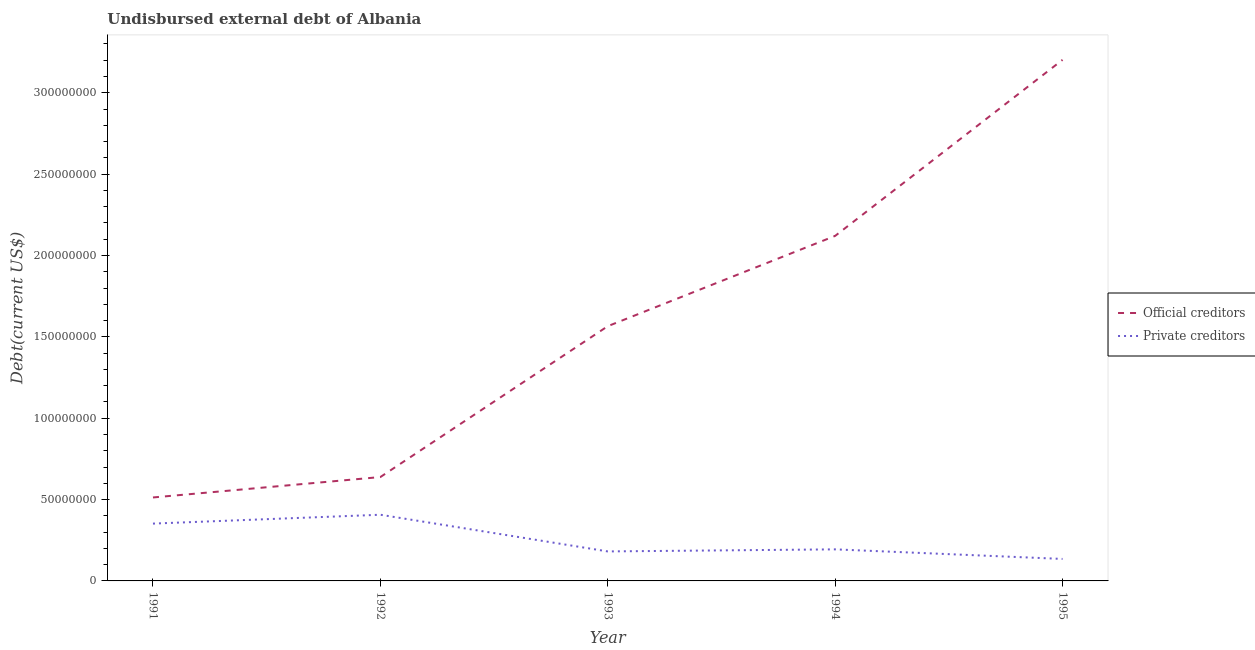Is the number of lines equal to the number of legend labels?
Ensure brevity in your answer.  Yes. What is the undisbursed external debt of private creditors in 1993?
Your answer should be very brief. 1.81e+07. Across all years, what is the maximum undisbursed external debt of official creditors?
Your answer should be very brief. 3.20e+08. Across all years, what is the minimum undisbursed external debt of private creditors?
Make the answer very short. 1.35e+07. In which year was the undisbursed external debt of official creditors minimum?
Keep it short and to the point. 1991. What is the total undisbursed external debt of private creditors in the graph?
Offer a very short reply. 1.27e+08. What is the difference between the undisbursed external debt of private creditors in 1993 and that in 1994?
Ensure brevity in your answer.  -1.27e+06. What is the difference between the undisbursed external debt of official creditors in 1991 and the undisbursed external debt of private creditors in 1994?
Your answer should be very brief. 3.19e+07. What is the average undisbursed external debt of private creditors per year?
Make the answer very short. 2.54e+07. In the year 1994, what is the difference between the undisbursed external debt of official creditors and undisbursed external debt of private creditors?
Your response must be concise. 1.93e+08. In how many years, is the undisbursed external debt of official creditors greater than 80000000 US$?
Provide a succinct answer. 3. What is the ratio of the undisbursed external debt of official creditors in 1992 to that in 1994?
Give a very brief answer. 0.3. Is the difference between the undisbursed external debt of official creditors in 1994 and 1995 greater than the difference between the undisbursed external debt of private creditors in 1994 and 1995?
Your response must be concise. No. What is the difference between the highest and the second highest undisbursed external debt of private creditors?
Make the answer very short. 5.44e+06. What is the difference between the highest and the lowest undisbursed external debt of private creditors?
Offer a very short reply. 2.72e+07. In how many years, is the undisbursed external debt of private creditors greater than the average undisbursed external debt of private creditors taken over all years?
Provide a succinct answer. 2. Does the undisbursed external debt of private creditors monotonically increase over the years?
Give a very brief answer. No. Is the undisbursed external debt of official creditors strictly greater than the undisbursed external debt of private creditors over the years?
Provide a short and direct response. Yes. Is the undisbursed external debt of private creditors strictly less than the undisbursed external debt of official creditors over the years?
Your response must be concise. Yes. How many years are there in the graph?
Your response must be concise. 5. Are the values on the major ticks of Y-axis written in scientific E-notation?
Your answer should be very brief. No. Does the graph contain any zero values?
Your answer should be compact. No. How many legend labels are there?
Make the answer very short. 2. How are the legend labels stacked?
Give a very brief answer. Vertical. What is the title of the graph?
Provide a succinct answer. Undisbursed external debt of Albania. Does "Electricity and heat production" appear as one of the legend labels in the graph?
Offer a terse response. No. What is the label or title of the Y-axis?
Make the answer very short. Debt(current US$). What is the Debt(current US$) of Official creditors in 1991?
Your answer should be very brief. 5.13e+07. What is the Debt(current US$) of Private creditors in 1991?
Make the answer very short. 3.52e+07. What is the Debt(current US$) of Official creditors in 1992?
Keep it short and to the point. 6.38e+07. What is the Debt(current US$) in Private creditors in 1992?
Give a very brief answer. 4.07e+07. What is the Debt(current US$) in Official creditors in 1993?
Offer a very short reply. 1.57e+08. What is the Debt(current US$) of Private creditors in 1993?
Keep it short and to the point. 1.81e+07. What is the Debt(current US$) in Official creditors in 1994?
Your response must be concise. 2.12e+08. What is the Debt(current US$) of Private creditors in 1994?
Offer a terse response. 1.94e+07. What is the Debt(current US$) in Official creditors in 1995?
Offer a very short reply. 3.20e+08. What is the Debt(current US$) of Private creditors in 1995?
Your response must be concise. 1.35e+07. Across all years, what is the maximum Debt(current US$) of Official creditors?
Your response must be concise. 3.20e+08. Across all years, what is the maximum Debt(current US$) of Private creditors?
Ensure brevity in your answer.  4.07e+07. Across all years, what is the minimum Debt(current US$) of Official creditors?
Offer a terse response. 5.13e+07. Across all years, what is the minimum Debt(current US$) in Private creditors?
Provide a succinct answer. 1.35e+07. What is the total Debt(current US$) in Official creditors in the graph?
Provide a succinct answer. 8.04e+08. What is the total Debt(current US$) of Private creditors in the graph?
Your answer should be very brief. 1.27e+08. What is the difference between the Debt(current US$) in Official creditors in 1991 and that in 1992?
Your answer should be very brief. -1.25e+07. What is the difference between the Debt(current US$) of Private creditors in 1991 and that in 1992?
Provide a succinct answer. -5.44e+06. What is the difference between the Debt(current US$) in Official creditors in 1991 and that in 1993?
Ensure brevity in your answer.  -1.05e+08. What is the difference between the Debt(current US$) in Private creditors in 1991 and that in 1993?
Your response must be concise. 1.71e+07. What is the difference between the Debt(current US$) in Official creditors in 1991 and that in 1994?
Provide a succinct answer. -1.61e+08. What is the difference between the Debt(current US$) in Private creditors in 1991 and that in 1994?
Keep it short and to the point. 1.58e+07. What is the difference between the Debt(current US$) in Official creditors in 1991 and that in 1995?
Provide a short and direct response. -2.69e+08. What is the difference between the Debt(current US$) of Private creditors in 1991 and that in 1995?
Your answer should be compact. 2.17e+07. What is the difference between the Debt(current US$) of Official creditors in 1992 and that in 1993?
Your answer should be compact. -9.27e+07. What is the difference between the Debt(current US$) in Private creditors in 1992 and that in 1993?
Give a very brief answer. 2.25e+07. What is the difference between the Debt(current US$) in Official creditors in 1992 and that in 1994?
Provide a short and direct response. -1.48e+08. What is the difference between the Debt(current US$) in Private creditors in 1992 and that in 1994?
Provide a succinct answer. 2.13e+07. What is the difference between the Debt(current US$) of Official creditors in 1992 and that in 1995?
Provide a succinct answer. -2.56e+08. What is the difference between the Debt(current US$) of Private creditors in 1992 and that in 1995?
Offer a very short reply. 2.72e+07. What is the difference between the Debt(current US$) of Official creditors in 1993 and that in 1994?
Give a very brief answer. -5.55e+07. What is the difference between the Debt(current US$) of Private creditors in 1993 and that in 1994?
Offer a terse response. -1.27e+06. What is the difference between the Debt(current US$) in Official creditors in 1993 and that in 1995?
Keep it short and to the point. -1.64e+08. What is the difference between the Debt(current US$) in Private creditors in 1993 and that in 1995?
Keep it short and to the point. 4.62e+06. What is the difference between the Debt(current US$) of Official creditors in 1994 and that in 1995?
Provide a succinct answer. -1.08e+08. What is the difference between the Debt(current US$) of Private creditors in 1994 and that in 1995?
Make the answer very short. 5.89e+06. What is the difference between the Debt(current US$) of Official creditors in 1991 and the Debt(current US$) of Private creditors in 1992?
Make the answer very short. 1.06e+07. What is the difference between the Debt(current US$) in Official creditors in 1991 and the Debt(current US$) in Private creditors in 1993?
Your answer should be very brief. 3.32e+07. What is the difference between the Debt(current US$) of Official creditors in 1991 and the Debt(current US$) of Private creditors in 1994?
Keep it short and to the point. 3.19e+07. What is the difference between the Debt(current US$) of Official creditors in 1991 and the Debt(current US$) of Private creditors in 1995?
Ensure brevity in your answer.  3.78e+07. What is the difference between the Debt(current US$) in Official creditors in 1992 and the Debt(current US$) in Private creditors in 1993?
Make the answer very short. 4.57e+07. What is the difference between the Debt(current US$) of Official creditors in 1992 and the Debt(current US$) of Private creditors in 1994?
Keep it short and to the point. 4.44e+07. What is the difference between the Debt(current US$) of Official creditors in 1992 and the Debt(current US$) of Private creditors in 1995?
Your answer should be compact. 5.03e+07. What is the difference between the Debt(current US$) in Official creditors in 1993 and the Debt(current US$) in Private creditors in 1994?
Your answer should be compact. 1.37e+08. What is the difference between the Debt(current US$) of Official creditors in 1993 and the Debt(current US$) of Private creditors in 1995?
Give a very brief answer. 1.43e+08. What is the difference between the Debt(current US$) of Official creditors in 1994 and the Debt(current US$) of Private creditors in 1995?
Your answer should be compact. 1.99e+08. What is the average Debt(current US$) in Official creditors per year?
Your answer should be compact. 1.61e+08. What is the average Debt(current US$) in Private creditors per year?
Keep it short and to the point. 2.54e+07. In the year 1991, what is the difference between the Debt(current US$) in Official creditors and Debt(current US$) in Private creditors?
Offer a very short reply. 1.61e+07. In the year 1992, what is the difference between the Debt(current US$) of Official creditors and Debt(current US$) of Private creditors?
Offer a terse response. 2.32e+07. In the year 1993, what is the difference between the Debt(current US$) in Official creditors and Debt(current US$) in Private creditors?
Keep it short and to the point. 1.38e+08. In the year 1994, what is the difference between the Debt(current US$) of Official creditors and Debt(current US$) of Private creditors?
Make the answer very short. 1.93e+08. In the year 1995, what is the difference between the Debt(current US$) in Official creditors and Debt(current US$) in Private creditors?
Offer a terse response. 3.07e+08. What is the ratio of the Debt(current US$) in Official creditors in 1991 to that in 1992?
Ensure brevity in your answer.  0.8. What is the ratio of the Debt(current US$) of Private creditors in 1991 to that in 1992?
Offer a very short reply. 0.87. What is the ratio of the Debt(current US$) of Official creditors in 1991 to that in 1993?
Make the answer very short. 0.33. What is the ratio of the Debt(current US$) of Private creditors in 1991 to that in 1993?
Keep it short and to the point. 1.94. What is the ratio of the Debt(current US$) in Official creditors in 1991 to that in 1994?
Your answer should be very brief. 0.24. What is the ratio of the Debt(current US$) of Private creditors in 1991 to that in 1994?
Your response must be concise. 1.82. What is the ratio of the Debt(current US$) of Official creditors in 1991 to that in 1995?
Make the answer very short. 0.16. What is the ratio of the Debt(current US$) in Private creditors in 1991 to that in 1995?
Your answer should be compact. 2.61. What is the ratio of the Debt(current US$) in Official creditors in 1992 to that in 1993?
Provide a succinct answer. 0.41. What is the ratio of the Debt(current US$) in Private creditors in 1992 to that in 1993?
Your answer should be compact. 2.24. What is the ratio of the Debt(current US$) of Official creditors in 1992 to that in 1994?
Keep it short and to the point. 0.3. What is the ratio of the Debt(current US$) of Private creditors in 1992 to that in 1994?
Your answer should be very brief. 2.1. What is the ratio of the Debt(current US$) of Official creditors in 1992 to that in 1995?
Provide a short and direct response. 0.2. What is the ratio of the Debt(current US$) in Private creditors in 1992 to that in 1995?
Offer a terse response. 3.01. What is the ratio of the Debt(current US$) in Official creditors in 1993 to that in 1994?
Ensure brevity in your answer.  0.74. What is the ratio of the Debt(current US$) of Private creditors in 1993 to that in 1994?
Your answer should be compact. 0.93. What is the ratio of the Debt(current US$) of Official creditors in 1993 to that in 1995?
Offer a terse response. 0.49. What is the ratio of the Debt(current US$) in Private creditors in 1993 to that in 1995?
Offer a very short reply. 1.34. What is the ratio of the Debt(current US$) of Official creditors in 1994 to that in 1995?
Your answer should be very brief. 0.66. What is the ratio of the Debt(current US$) of Private creditors in 1994 to that in 1995?
Make the answer very short. 1.44. What is the difference between the highest and the second highest Debt(current US$) of Official creditors?
Ensure brevity in your answer.  1.08e+08. What is the difference between the highest and the second highest Debt(current US$) in Private creditors?
Keep it short and to the point. 5.44e+06. What is the difference between the highest and the lowest Debt(current US$) in Official creditors?
Ensure brevity in your answer.  2.69e+08. What is the difference between the highest and the lowest Debt(current US$) of Private creditors?
Offer a very short reply. 2.72e+07. 